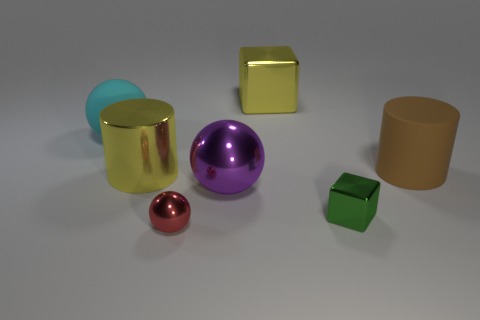Add 1 large metallic cylinders. How many objects exist? 8 Subtract all cubes. How many objects are left? 5 Subtract 1 red balls. How many objects are left? 6 Subtract all brown matte cylinders. Subtract all tiny cubes. How many objects are left? 5 Add 3 large balls. How many large balls are left? 5 Add 7 big blue metallic cylinders. How many big blue metallic cylinders exist? 7 